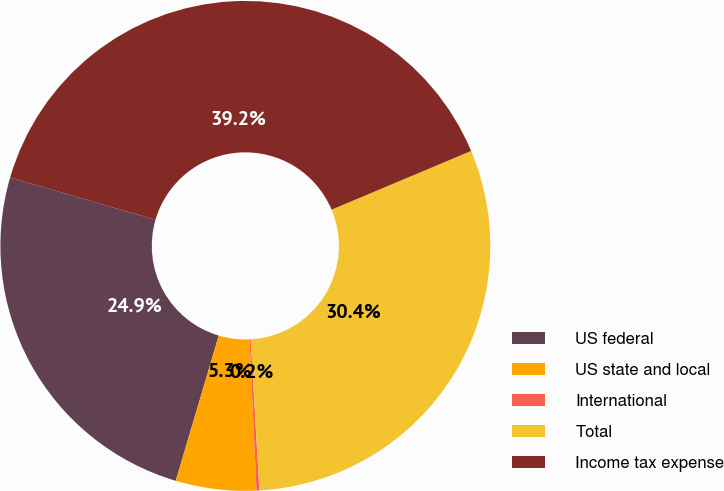<chart> <loc_0><loc_0><loc_500><loc_500><pie_chart><fcel>US federal<fcel>US state and local<fcel>International<fcel>Total<fcel>Income tax expense<nl><fcel>24.92%<fcel>5.31%<fcel>0.19%<fcel>30.42%<fcel>39.16%<nl></chart> 